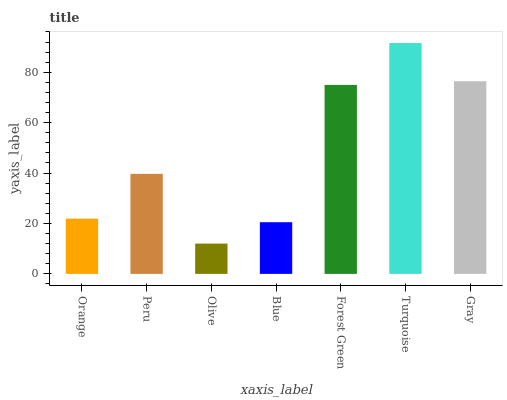Is Olive the minimum?
Answer yes or no. Yes. Is Turquoise the maximum?
Answer yes or no. Yes. Is Peru the minimum?
Answer yes or no. No. Is Peru the maximum?
Answer yes or no. No. Is Peru greater than Orange?
Answer yes or no. Yes. Is Orange less than Peru?
Answer yes or no. Yes. Is Orange greater than Peru?
Answer yes or no. No. Is Peru less than Orange?
Answer yes or no. No. Is Peru the high median?
Answer yes or no. Yes. Is Peru the low median?
Answer yes or no. Yes. Is Forest Green the high median?
Answer yes or no. No. Is Gray the low median?
Answer yes or no. No. 